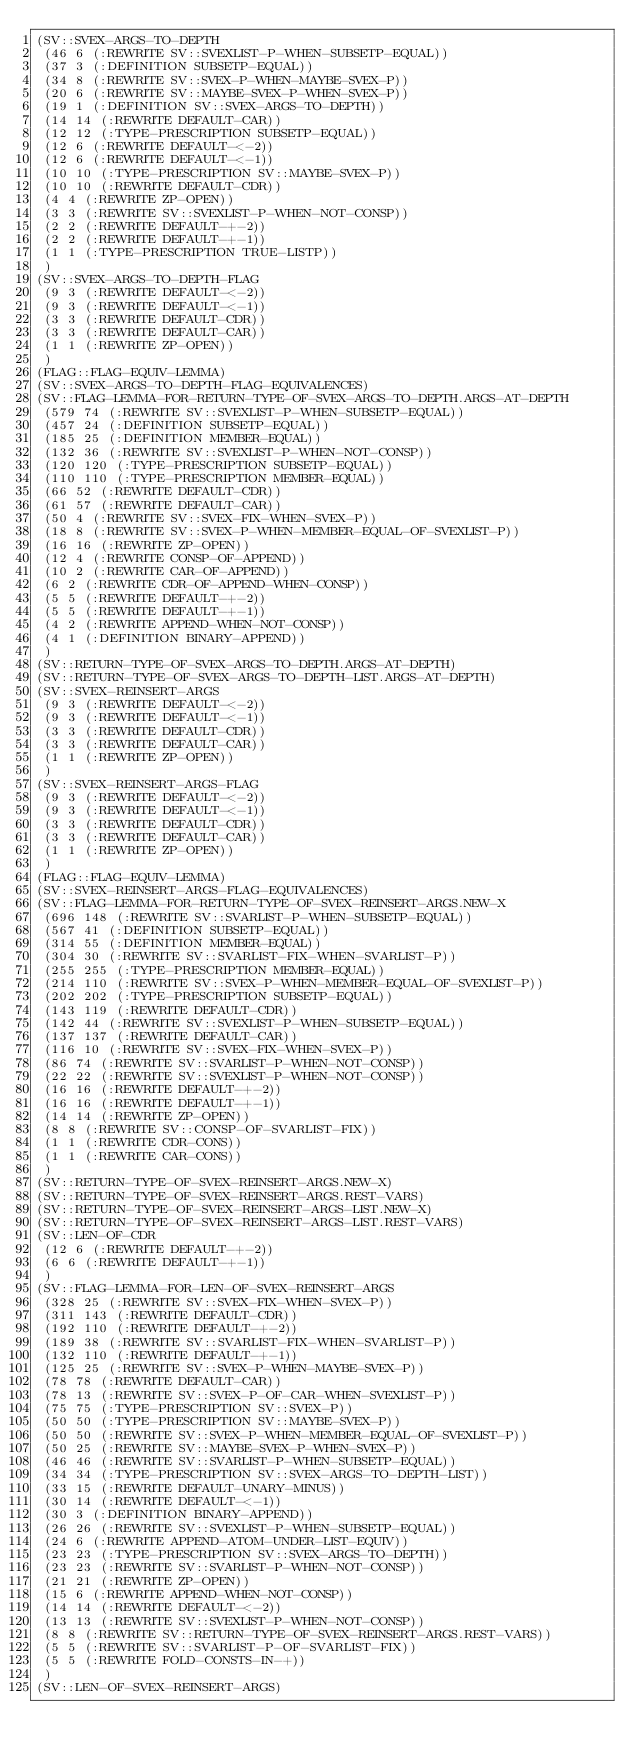Convert code to text. <code><loc_0><loc_0><loc_500><loc_500><_Lisp_>(SV::SVEX-ARGS-TO-DEPTH
 (46 6 (:REWRITE SV::SVEXLIST-P-WHEN-SUBSETP-EQUAL))
 (37 3 (:DEFINITION SUBSETP-EQUAL))
 (34 8 (:REWRITE SV::SVEX-P-WHEN-MAYBE-SVEX-P))
 (20 6 (:REWRITE SV::MAYBE-SVEX-P-WHEN-SVEX-P))
 (19 1 (:DEFINITION SV::SVEX-ARGS-TO-DEPTH))
 (14 14 (:REWRITE DEFAULT-CAR))
 (12 12 (:TYPE-PRESCRIPTION SUBSETP-EQUAL))
 (12 6 (:REWRITE DEFAULT-<-2))
 (12 6 (:REWRITE DEFAULT-<-1))
 (10 10 (:TYPE-PRESCRIPTION SV::MAYBE-SVEX-P))
 (10 10 (:REWRITE DEFAULT-CDR))
 (4 4 (:REWRITE ZP-OPEN))
 (3 3 (:REWRITE SV::SVEXLIST-P-WHEN-NOT-CONSP))
 (2 2 (:REWRITE DEFAULT-+-2))
 (2 2 (:REWRITE DEFAULT-+-1))
 (1 1 (:TYPE-PRESCRIPTION TRUE-LISTP))
 )
(SV::SVEX-ARGS-TO-DEPTH-FLAG
 (9 3 (:REWRITE DEFAULT-<-2))
 (9 3 (:REWRITE DEFAULT-<-1))
 (3 3 (:REWRITE DEFAULT-CDR))
 (3 3 (:REWRITE DEFAULT-CAR))
 (1 1 (:REWRITE ZP-OPEN))
 )
(FLAG::FLAG-EQUIV-LEMMA)
(SV::SVEX-ARGS-TO-DEPTH-FLAG-EQUIVALENCES)
(SV::FLAG-LEMMA-FOR-RETURN-TYPE-OF-SVEX-ARGS-TO-DEPTH.ARGS-AT-DEPTH
 (579 74 (:REWRITE SV::SVEXLIST-P-WHEN-SUBSETP-EQUAL))
 (457 24 (:DEFINITION SUBSETP-EQUAL))
 (185 25 (:DEFINITION MEMBER-EQUAL))
 (132 36 (:REWRITE SV::SVEXLIST-P-WHEN-NOT-CONSP))
 (120 120 (:TYPE-PRESCRIPTION SUBSETP-EQUAL))
 (110 110 (:TYPE-PRESCRIPTION MEMBER-EQUAL))
 (66 52 (:REWRITE DEFAULT-CDR))
 (61 57 (:REWRITE DEFAULT-CAR))
 (50 4 (:REWRITE SV::SVEX-FIX-WHEN-SVEX-P))
 (18 8 (:REWRITE SV::SVEX-P-WHEN-MEMBER-EQUAL-OF-SVEXLIST-P))
 (16 16 (:REWRITE ZP-OPEN))
 (12 4 (:REWRITE CONSP-OF-APPEND))
 (10 2 (:REWRITE CAR-OF-APPEND))
 (6 2 (:REWRITE CDR-OF-APPEND-WHEN-CONSP))
 (5 5 (:REWRITE DEFAULT-+-2))
 (5 5 (:REWRITE DEFAULT-+-1))
 (4 2 (:REWRITE APPEND-WHEN-NOT-CONSP))
 (4 1 (:DEFINITION BINARY-APPEND))
 )
(SV::RETURN-TYPE-OF-SVEX-ARGS-TO-DEPTH.ARGS-AT-DEPTH)
(SV::RETURN-TYPE-OF-SVEX-ARGS-TO-DEPTH-LIST.ARGS-AT-DEPTH)
(SV::SVEX-REINSERT-ARGS
 (9 3 (:REWRITE DEFAULT-<-2))
 (9 3 (:REWRITE DEFAULT-<-1))
 (3 3 (:REWRITE DEFAULT-CDR))
 (3 3 (:REWRITE DEFAULT-CAR))
 (1 1 (:REWRITE ZP-OPEN))
 )
(SV::SVEX-REINSERT-ARGS-FLAG
 (9 3 (:REWRITE DEFAULT-<-2))
 (9 3 (:REWRITE DEFAULT-<-1))
 (3 3 (:REWRITE DEFAULT-CDR))
 (3 3 (:REWRITE DEFAULT-CAR))
 (1 1 (:REWRITE ZP-OPEN))
 )
(FLAG::FLAG-EQUIV-LEMMA)
(SV::SVEX-REINSERT-ARGS-FLAG-EQUIVALENCES)
(SV::FLAG-LEMMA-FOR-RETURN-TYPE-OF-SVEX-REINSERT-ARGS.NEW-X
 (696 148 (:REWRITE SV::SVARLIST-P-WHEN-SUBSETP-EQUAL))
 (567 41 (:DEFINITION SUBSETP-EQUAL))
 (314 55 (:DEFINITION MEMBER-EQUAL))
 (304 30 (:REWRITE SV::SVARLIST-FIX-WHEN-SVARLIST-P))
 (255 255 (:TYPE-PRESCRIPTION MEMBER-EQUAL))
 (214 110 (:REWRITE SV::SVEX-P-WHEN-MEMBER-EQUAL-OF-SVEXLIST-P))
 (202 202 (:TYPE-PRESCRIPTION SUBSETP-EQUAL))
 (143 119 (:REWRITE DEFAULT-CDR))
 (142 44 (:REWRITE SV::SVEXLIST-P-WHEN-SUBSETP-EQUAL))
 (137 137 (:REWRITE DEFAULT-CAR))
 (116 10 (:REWRITE SV::SVEX-FIX-WHEN-SVEX-P))
 (86 74 (:REWRITE SV::SVARLIST-P-WHEN-NOT-CONSP))
 (22 22 (:REWRITE SV::SVEXLIST-P-WHEN-NOT-CONSP))
 (16 16 (:REWRITE DEFAULT-+-2))
 (16 16 (:REWRITE DEFAULT-+-1))
 (14 14 (:REWRITE ZP-OPEN))
 (8 8 (:REWRITE SV::CONSP-OF-SVARLIST-FIX))
 (1 1 (:REWRITE CDR-CONS))
 (1 1 (:REWRITE CAR-CONS))
 )
(SV::RETURN-TYPE-OF-SVEX-REINSERT-ARGS.NEW-X)
(SV::RETURN-TYPE-OF-SVEX-REINSERT-ARGS.REST-VARS)
(SV::RETURN-TYPE-OF-SVEX-REINSERT-ARGS-LIST.NEW-X)
(SV::RETURN-TYPE-OF-SVEX-REINSERT-ARGS-LIST.REST-VARS)
(SV::LEN-OF-CDR
 (12 6 (:REWRITE DEFAULT-+-2))
 (6 6 (:REWRITE DEFAULT-+-1))
 )
(SV::FLAG-LEMMA-FOR-LEN-OF-SVEX-REINSERT-ARGS
 (328 25 (:REWRITE SV::SVEX-FIX-WHEN-SVEX-P))
 (311 143 (:REWRITE DEFAULT-CDR))
 (192 110 (:REWRITE DEFAULT-+-2))
 (189 38 (:REWRITE SV::SVARLIST-FIX-WHEN-SVARLIST-P))
 (132 110 (:REWRITE DEFAULT-+-1))
 (125 25 (:REWRITE SV::SVEX-P-WHEN-MAYBE-SVEX-P))
 (78 78 (:REWRITE DEFAULT-CAR))
 (78 13 (:REWRITE SV::SVEX-P-OF-CAR-WHEN-SVEXLIST-P))
 (75 75 (:TYPE-PRESCRIPTION SV::SVEX-P))
 (50 50 (:TYPE-PRESCRIPTION SV::MAYBE-SVEX-P))
 (50 50 (:REWRITE SV::SVEX-P-WHEN-MEMBER-EQUAL-OF-SVEXLIST-P))
 (50 25 (:REWRITE SV::MAYBE-SVEX-P-WHEN-SVEX-P))
 (46 46 (:REWRITE SV::SVARLIST-P-WHEN-SUBSETP-EQUAL))
 (34 34 (:TYPE-PRESCRIPTION SV::SVEX-ARGS-TO-DEPTH-LIST))
 (33 15 (:REWRITE DEFAULT-UNARY-MINUS))
 (30 14 (:REWRITE DEFAULT-<-1))
 (30 3 (:DEFINITION BINARY-APPEND))
 (26 26 (:REWRITE SV::SVEXLIST-P-WHEN-SUBSETP-EQUAL))
 (24 6 (:REWRITE APPEND-ATOM-UNDER-LIST-EQUIV))
 (23 23 (:TYPE-PRESCRIPTION SV::SVEX-ARGS-TO-DEPTH))
 (23 23 (:REWRITE SV::SVARLIST-P-WHEN-NOT-CONSP))
 (21 21 (:REWRITE ZP-OPEN))
 (15 6 (:REWRITE APPEND-WHEN-NOT-CONSP))
 (14 14 (:REWRITE DEFAULT-<-2))
 (13 13 (:REWRITE SV::SVEXLIST-P-WHEN-NOT-CONSP))
 (8 8 (:REWRITE SV::RETURN-TYPE-OF-SVEX-REINSERT-ARGS.REST-VARS))
 (5 5 (:REWRITE SV::SVARLIST-P-OF-SVARLIST-FIX))
 (5 5 (:REWRITE FOLD-CONSTS-IN-+))
 )
(SV::LEN-OF-SVEX-REINSERT-ARGS)</code> 